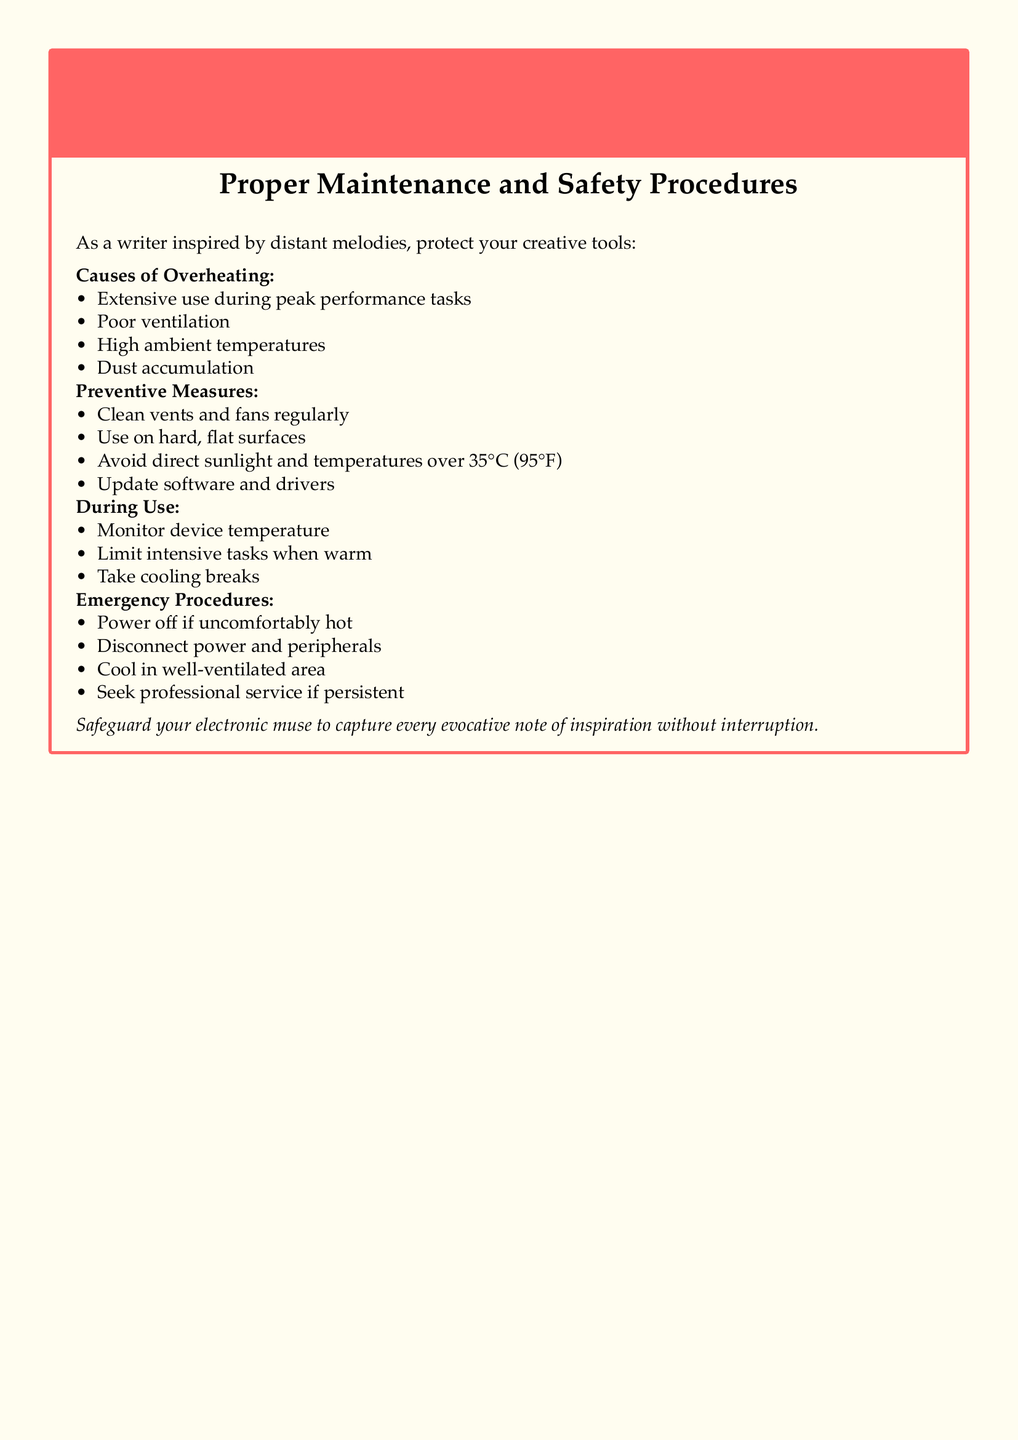What is the title of the document? The title is clearly stated in the document as "Warning: Overheating Hazard of Electronic Writing Devices."
Answer: Warning: Overheating Hazard of Electronic Writing Devices What color is used for the box frame? The color of the box frame is specified in the document, which is warning red.
Answer: warning red What is one cause of overheating? One cause of overheating mentioned in the document is "Extensive use during peak performance tasks."
Answer: Extensive use during peak performance tasks What temperature should be avoided to prevent overheating? The document specifies to avoid temperatures over 35°C (95°F).
Answer: 35°C (95°F) What should you do if the device is uncomfortably hot? According to the document, you should "Power off if uncomfortably hot."
Answer: Power off if uncomfortably hot What is one preventive measure mentioned? The document lists "Clean vents and fans regularly" as a preventive measure.
Answer: Clean vents and fans regularly What type of area should you cool the device in? The document advises to cool the device in a "well-ventilated area."
Answer: well-ventilated area During use, what should you monitor? The document states to "Monitor device temperature" during use.
Answer: Monitor device temperature 